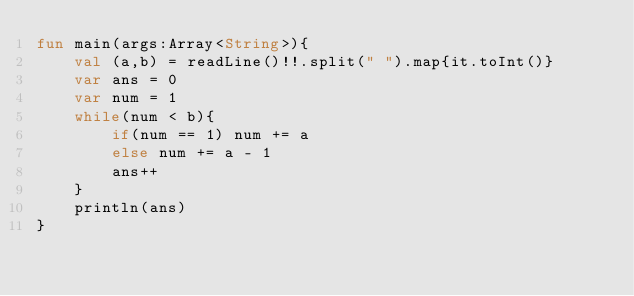Convert code to text. <code><loc_0><loc_0><loc_500><loc_500><_Kotlin_>fun main(args:Array<String>){
    val (a,b) = readLine()!!.split(" ").map{it.toInt()}
    var ans = 0
    var num = 1
    while(num < b){
        if(num == 1) num += a
        else num += a - 1
        ans++
    }
    println(ans)
}
</code> 